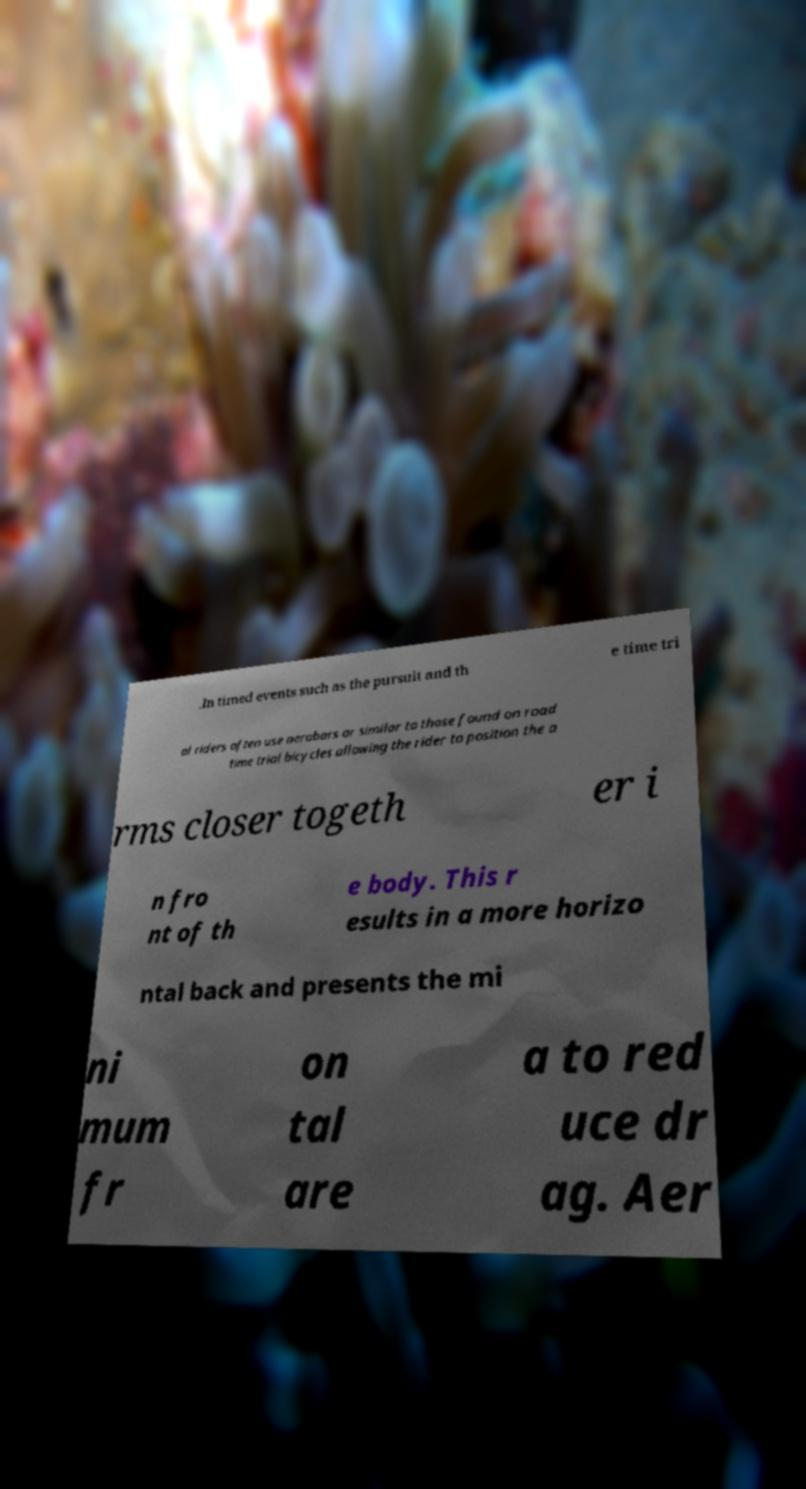There's text embedded in this image that I need extracted. Can you transcribe it verbatim? .In timed events such as the pursuit and th e time tri al riders often use aerobars or similar to those found on road time trial bicycles allowing the rider to position the a rms closer togeth er i n fro nt of th e body. This r esults in a more horizo ntal back and presents the mi ni mum fr on tal are a to red uce dr ag. Aer 